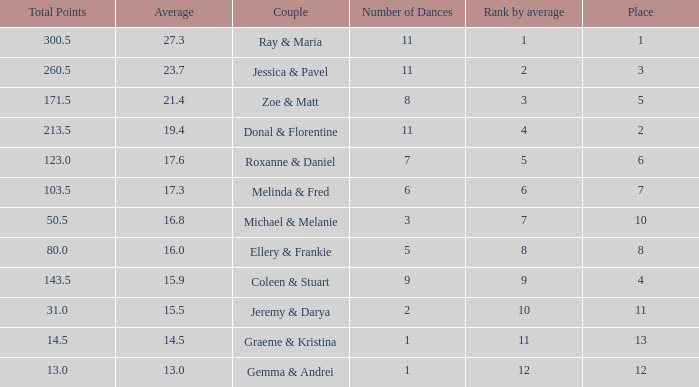What is the couples name where the average is 15.9? Coleen & Stuart. 